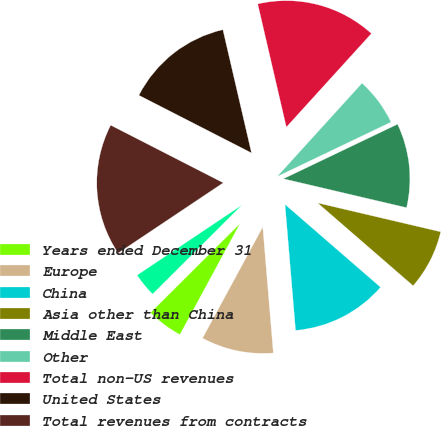Convert chart. <chart><loc_0><loc_0><loc_500><loc_500><pie_chart><fcel>Years ended December 31<fcel>Europe<fcel>China<fcel>Asia other than China<fcel>Middle East<fcel>Other<fcel>Total non-US revenues<fcel>United States<fcel>Total revenues from contracts<fcel>Intersegment revenues<nl><fcel>4.63%<fcel>9.23%<fcel>12.3%<fcel>7.7%<fcel>10.77%<fcel>6.16%<fcel>15.37%<fcel>13.84%<fcel>16.91%<fcel>3.09%<nl></chart> 